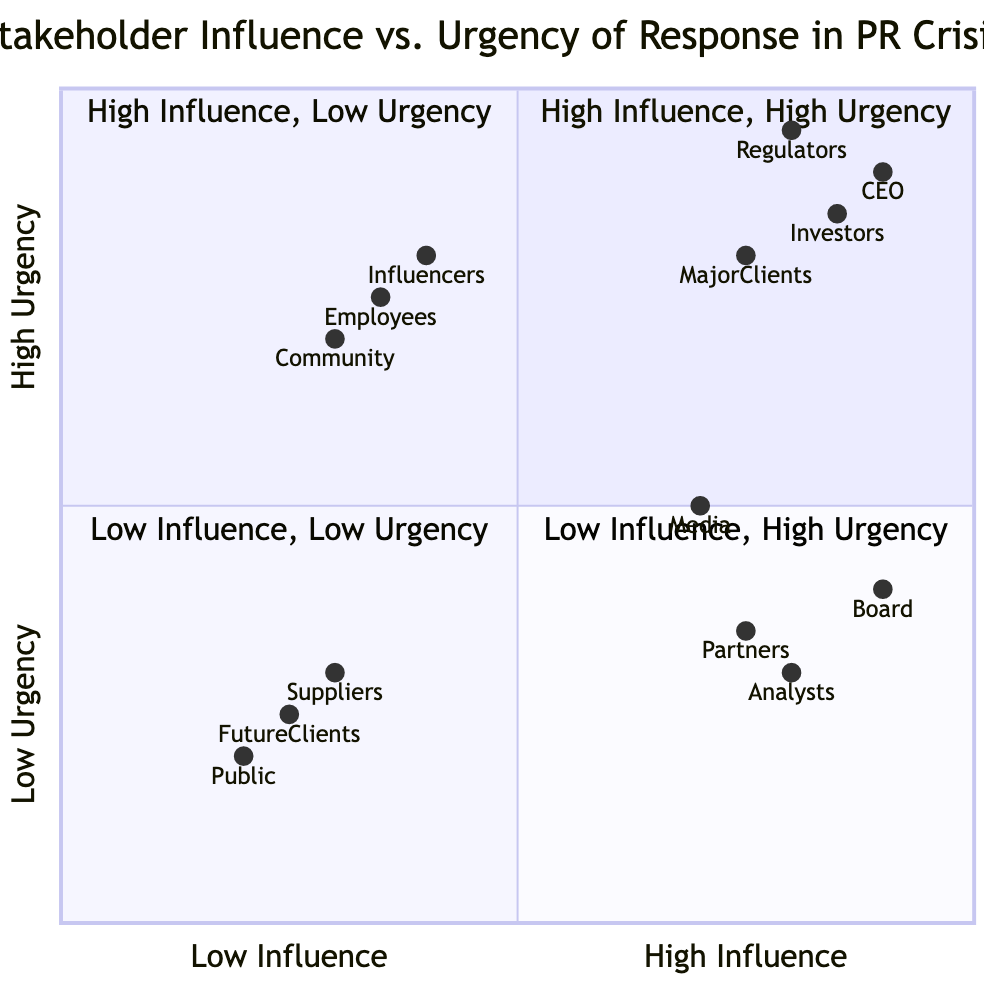What are examples of stakeholders in the High Influence, High Urgency quadrant? The High Influence, High Urgency quadrant includes stakeholders such as the CEO of the Company, Primary Investors, Regulatory Authorities, and Major Clients. These are all listed in the examples section of that specific quadrant.
Answer: CEO of the Company, Primary Investors, Regulatory Authorities, Major Clients How many quadrants are labeled "High Influence"? There are two quadrants labeled "High Influence": High Influence, High Urgency and High Influence, Low Urgency. This can be determined by counting the occurrences of "High Influence" in the quadrant names.
Answer: 2 Which stakeholder is positioned at the highest urgency level among all quadrants? The stakeholder positioned at the highest urgency level in the quadrants is the Regulatory Authorities, located in the High Influence, High Urgency quadrant, with a y-value of 0.95.
Answer: Regulatory Authorities What is the main requirement for stakeholders in the Low Influence, High Urgency quadrant? The stakeholders in the Low Influence, High Urgency quadrant require a rapid and empathetic response to manage perceptions and provide timely updates, as stated in the quadrant's characteristics.
Answer: Rapid and empathetic response Which quadrant contains the Board of Directors? The Board of Directors is located in the High Influence, Low Urgency quadrant, which can be concluded from the examples listed in that quadrant.
Answer: High Influence, Low Urgency Which stakeholder has the least influence according to the diagram? The stakeholder with the least influence according to the diagram is the General Public, indicated by the lowest x-value of 0.2 in the Low Influence, Low Urgency quadrant.
Answer: General Public How would you categorize the need for communication with social media influencers in a crisis? Social media influencers fall under the Low Influence, High Urgency category, which entails a need for swift responses to prevent escalation in the perceived crisis, as seen in the quadrant’s characteristics.
Answer: Low Influence, High Urgency How many total examples are provided for stakeholders in the Low Influence, Low Urgency quadrant? There are three examples of stakeholders in the Low Influence, Low Urgency quadrant: Broad General Public, Minor Suppliers, and Distant Future Clients, making a total of three examples listed.
Answer: 3 